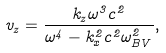Convert formula to latex. <formula><loc_0><loc_0><loc_500><loc_500>v _ { z } = \frac { k _ { z } \omega ^ { 3 } c ^ { 2 } } { \omega ^ { 4 } - k ^ { 2 } _ { x } c ^ { 2 } \omega _ { B V } ^ { 2 } } ,</formula> 